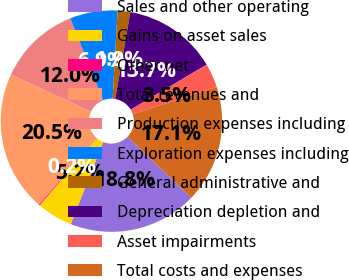Convert chart. <chart><loc_0><loc_0><loc_500><loc_500><pie_chart><fcel>Sales and other operating<fcel>Gains on asset sales<fcel>Other net<fcel>Total revenues and<fcel>Production expenses including<fcel>Exploration expenses including<fcel>General administrative and<fcel>Depreciation depletion and<fcel>Asset impairments<fcel>Total costs and expenses<nl><fcel>18.83%<fcel>5.24%<fcel>0.15%<fcel>20.53%<fcel>12.04%<fcel>6.94%<fcel>1.85%<fcel>13.74%<fcel>3.54%<fcel>17.14%<nl></chart> 